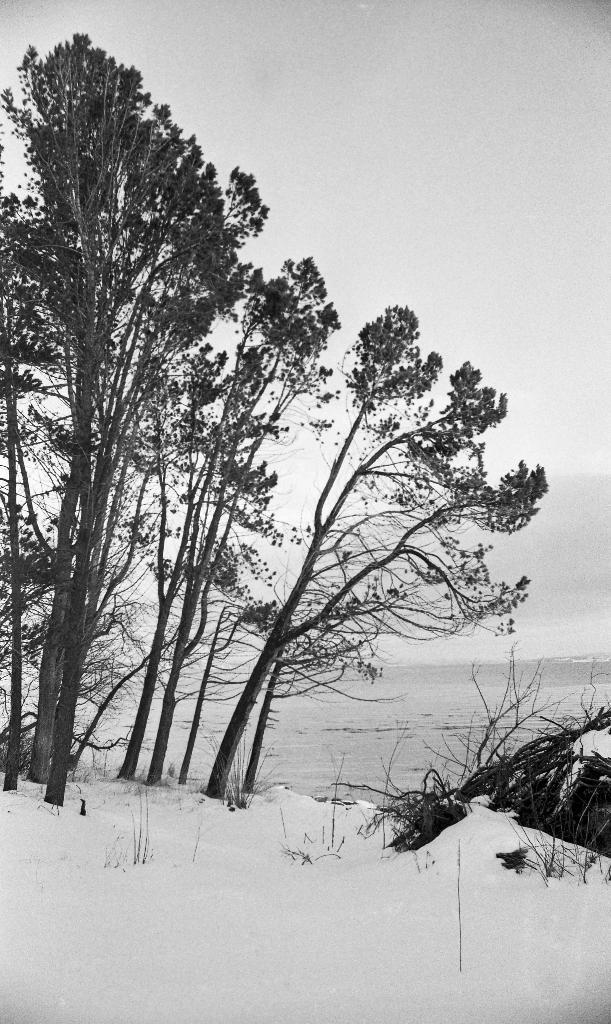What type of vegetation can be seen in the image? There are trees in the image. What is the weather like in the image? There is snow in the image, indicating a cold and likely wintery scene. What else is present in the image besides trees? There is water in the image. What is the color scheme of the image? The image is in black and white. Can you tell me how many straws are in the water in the image? There are no straws present in the image; it features trees, snow, and water in a black and white color scheme. What type of parent is shown taking care of the trees in the image? There is no parent or caretaker depicted in the image; it only shows trees, snow, water, and the black and white color scheme. 